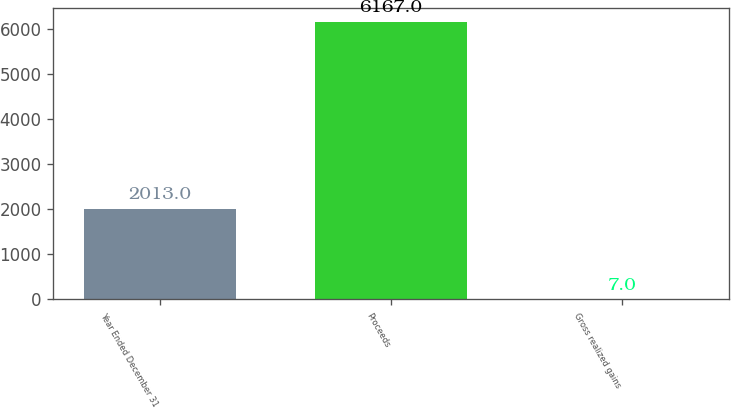Convert chart. <chart><loc_0><loc_0><loc_500><loc_500><bar_chart><fcel>Year Ended December 31<fcel>Proceeds<fcel>Gross realized gains<nl><fcel>2013<fcel>6167<fcel>7<nl></chart> 